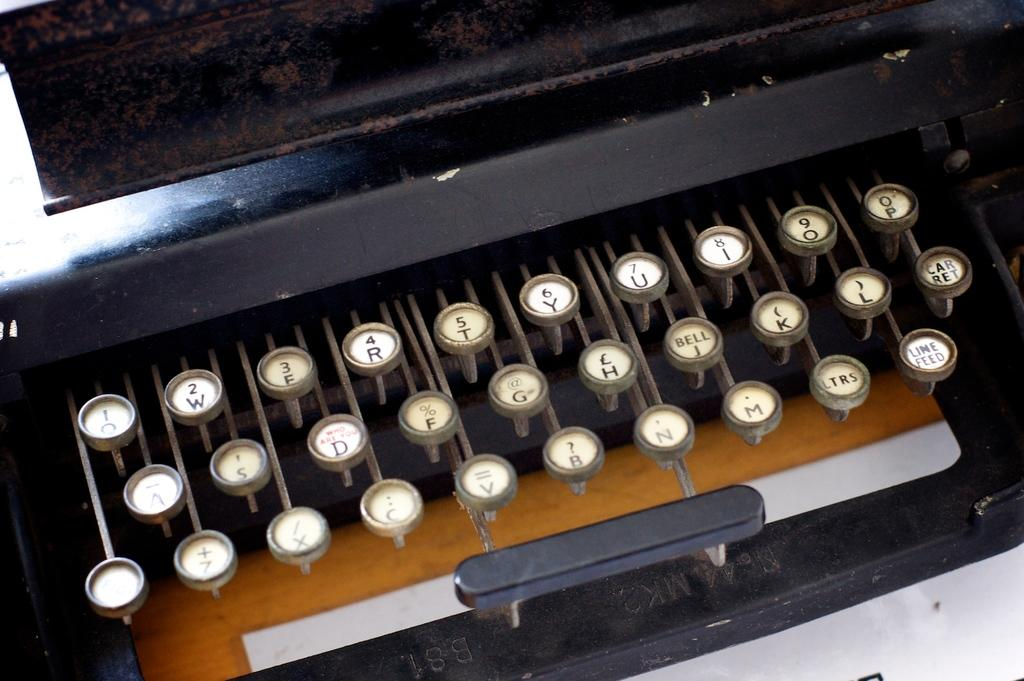<image>
Create a compact narrative representing the image presented. close up of old manual typewriter with keys showing q,w,e,r,t,y,u,i,o,p and somewhat less visible 2 rows below 